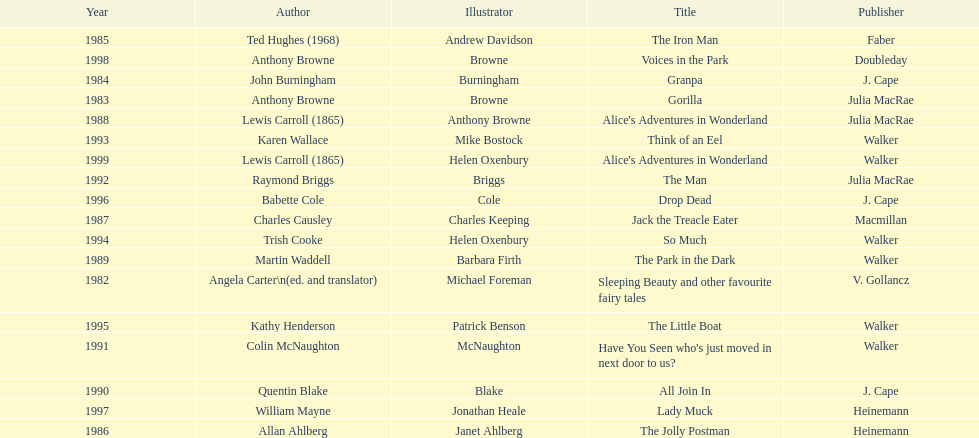What's the difference in years between angela carter's title and anthony browne's? 1. 